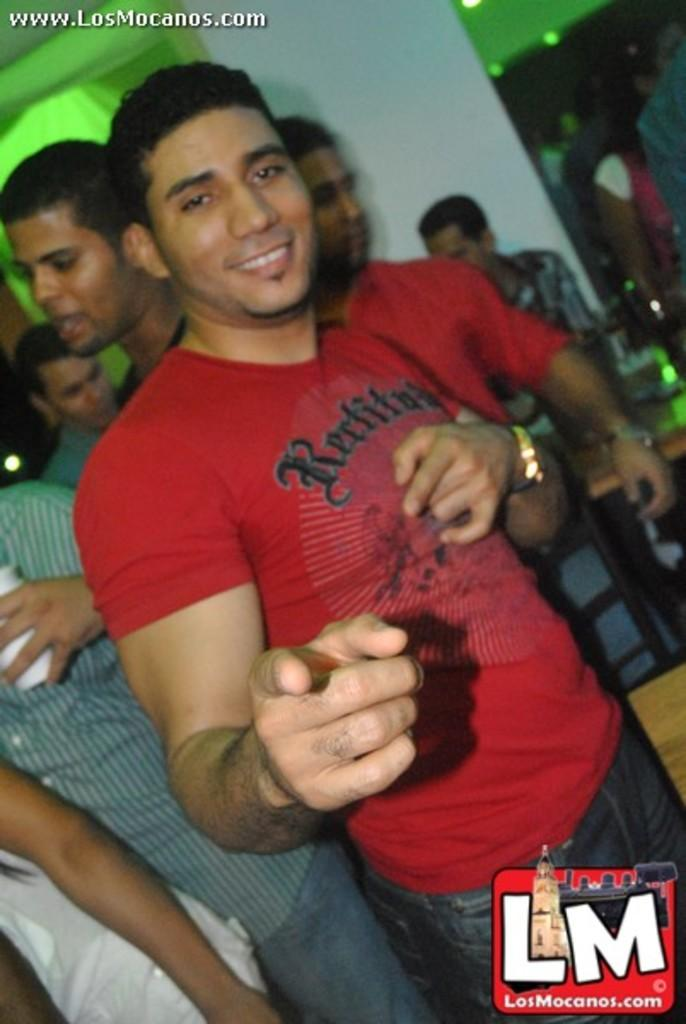What is the man in the image doing? The man in the image is standing and smiling. Can you describe the people in the background of the image? There is a group of people standing in the background of the image. Are there any visible marks on the image? Yes, there are watermarks on the image. What type of map can be seen in the image? There is no map present in the image. What kind of waste is being disposed of in the image? There is no waste disposal activity depicted in the image. 